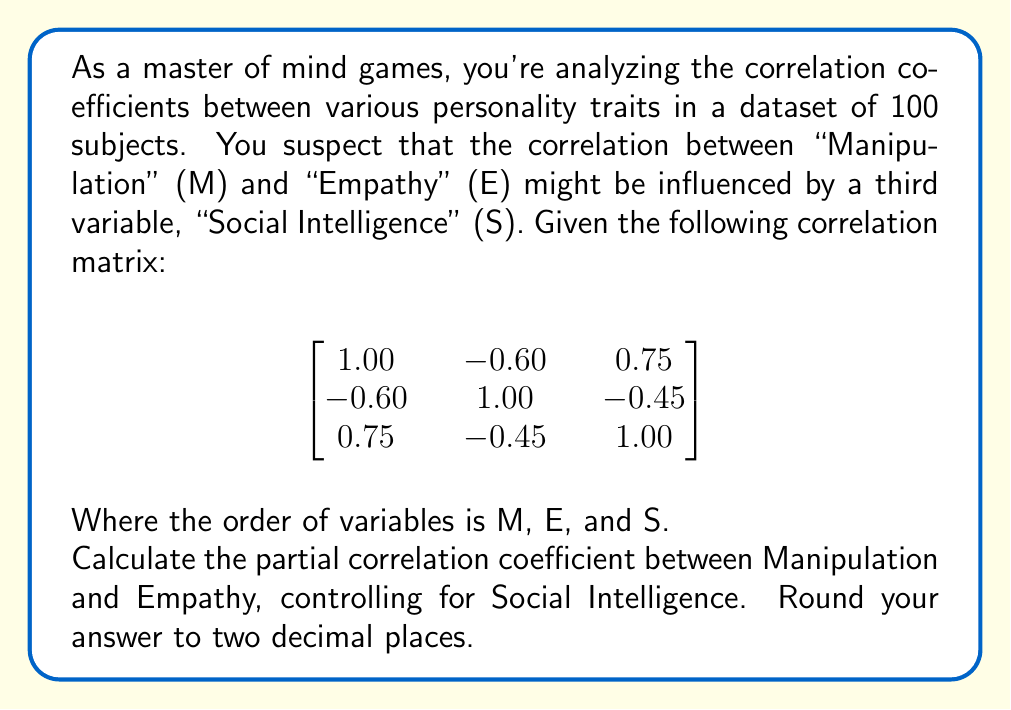Provide a solution to this math problem. To calculate the partial correlation coefficient between Manipulation (M) and Empathy (E), controlling for Social Intelligence (S), we'll use the following formula:

$$r_{ME.S} = \frac{r_{ME} - r_{MS}r_{ES}}{\sqrt{(1-r_{MS}^2)(1-r_{ES}^2)}}$$

Where:
$r_{ME.S}$ is the partial correlation coefficient
$r_{ME}$ is the correlation between M and E
$r_{MS}$ is the correlation between M and S
$r_{ES}$ is the correlation between E and S

Step 1: Identify the correlations from the matrix
$r_{ME} = -0.60$
$r_{MS} = 0.75$
$r_{ES} = -0.45$

Step 2: Substitute these values into the formula
$$r_{ME.S} = \frac{-0.60 - (0.75)(-0.45)}{\sqrt{(1-0.75^2)(1-(-0.45)^2)}}$$

Step 3: Calculate the numerator
$$-0.60 - (0.75)(-0.45) = -0.60 + 0.3375 = -0.2625$$

Step 4: Calculate the denominator
$$\sqrt{(1-0.75^2)(1-(-0.45)^2)} = \sqrt{(1-0.5625)(1-0.2025)} = \sqrt{0.4375 \times 0.7975} = \sqrt{0.3489} = 0.5907$$

Step 5: Divide the numerator by the denominator
$$r_{ME.S} = \frac{-0.2625}{0.5907} = -0.4444$$

Step 6: Round to two decimal places
$$r_{ME.S} \approx -0.44$$
Answer: -0.44 